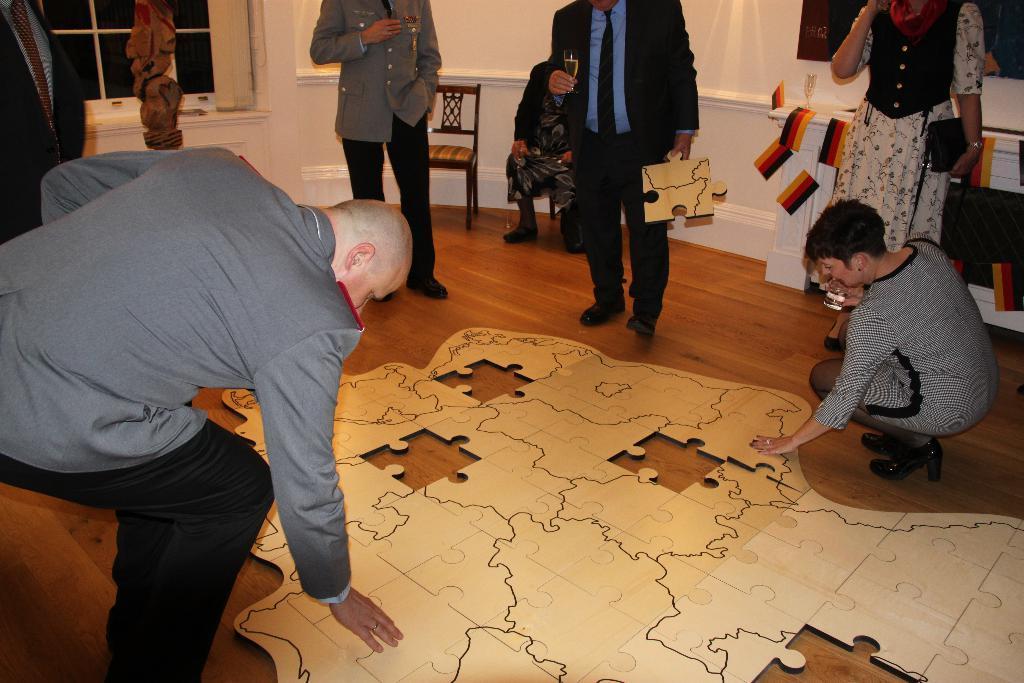How would you summarize this image in a sentence or two? There is a puzzle on the floor. People are standing. A person at the center is wearing a suit and holding a puzzle block and a glass of drink. Behind him there are chairs and a person is seated on a chair. There are flags at the right and a window at the left back. 